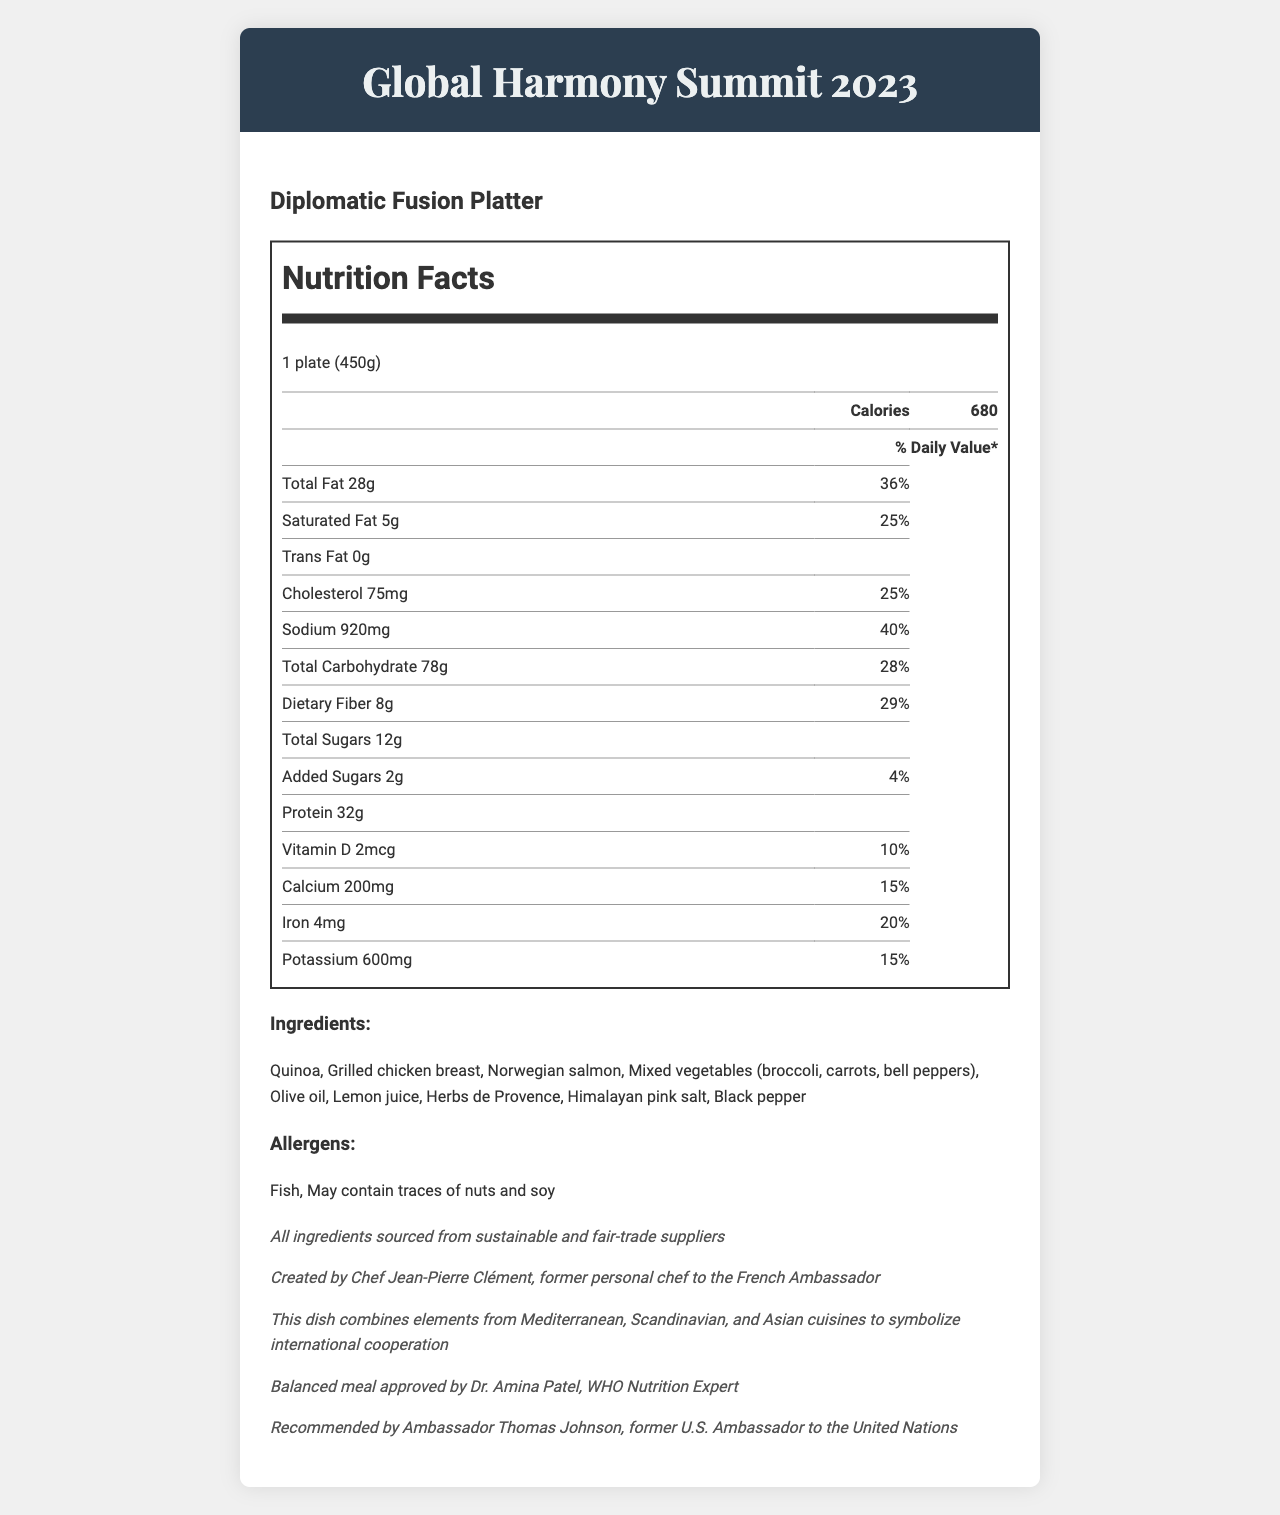what is the serving size of the Diplomatic Fusion Platter? The serving size is mentioned in the content section as "1 plate (450g)".
Answer: 1 plate (450g) how many calories are in one serving of the Diplomatic Fusion Platter? The calorie content is listed in bold under the nutrition facts section as "Calories 680".
Answer: 680 What is the main source of protein in the Diplomatic Fusion Platter? The ingredients list includes "Grilled chicken breast" and "Norwegian salmon," which are typically high in protein.
Answer: Grilled chicken breast, Norwegian salmon What is the daily value percentage for sodium? The sodium's daily value percentage is listed under the nutrition facts section as "Sodium 920mg 40%".
Answer: 40% Who created the Diplomatic Fusion Platter? The chef note states that the dish was created by Chef Jean-Pierre Clément.
Answer: Chef Jean-Pierre Clément Which ingredient is not included in the Diplomatic Fusion Platter? A. Quinoa B. Mixed vegetables C. Lentils D. Salmon The ingredients list does not mention "Lentils."
Answer: C. Lentils What is the daily value percentage for dietary fiber? A. 29% B. 28% C. 25% D. 20% The daily value percentage for dietary fiber is mentioned as "29%" under the nutrition facts section.
Answer: A. 29% Is the Diplomatic Fusion Platter suitable for individuals with a nut allergy? The allergens section states that the dish "May contain traces of nuts."
Answer: No Does the Diplomatic Fusion Platter include any added sugars? The document lists "Added Sugars 2g 4%" in the nutrition facts section.
Answer: Yes Briefly summarize the main idea of the document. The summary captures the essence of the document by detailing the nutritional information, ingredients, and additional notes on the preparation and approval of the Diplomatic Fusion Platter.
Answer: The document presents the nutrition facts, ingredients, and other details of the Diplomatic Fusion Platter served at the Global Harmony Summit 2023. It provides information on calorie content, daily value percentages for various nutrients, ingredients used, and any allergens present. The dish is created by Chef Jean-Pierre Clément and endorsed by notable figures, emphasizing its cultural fusion and sustainability. What is the total carbohydrate content of the Diplomatic Fusion Platter? The total carbohydrate content is stated as "Total Carbohydrate 78g" in the nutrition facts section.
Answer: 78g What is the daily value percentage for calcium? The daily value percentage for calcium is listed under the nutrition facts section as "Calcium 200mg 15%".
Answer: 15% What cuisines are combined in the Diplomatic Fusion Platter? The cultural fusion note mentions that the dish combines elements from Mediterranean, Scandinavian, and Asian cuisines.
Answer: Mediterranean, Scandinavian, and Asian cuisines What is the amount of potassium in the Diplomatic Fusion Platter? The potassium content is listed under the nutrition facts section as "Potassium 600mg".
Answer: 600mg Who approved the Diplomatic Fusion Platter as a balanced meal? The nutritionist approval note states that the balanced meal was approved by Dr. Amina Patel, WHO Nutrition Expert.
Answer: Dr. Amina Patel What is the percentage of daily value for vitamin D? A. 15% B. 20% C. 10% D. 5% The daily value percentage for vitamin D is listed as "Vitamin D 2mcg 10%" in the nutrition facts section.
Answer: C. 10% How many servings per container are there for the Diplomatic Fusion Platter? The servings per container are mentioned as "1" in the nutrition facts section.
Answer: 1 Who recommended the Diplomatic Fusion Platter? The ambassador endorsement note states that the dish is recommended by Ambassador Thomas Johnson, former U.S. Ambassador to the United Nations.
Answer: Ambassador Thomas Johnson What type of salt is used in the Diplomatic Fusion Platter? The ingredients section lists "Himalayan pink salt".
Answer: Himalayan pink salt How many grams of saturated fat are in the Diplomatic Fusion Platter? The saturated fat content is listed under the nutrition facts section as "Saturated Fat 5g".
Answer: 5g Explain the sustainability note mentioned in the document. The sustainability note explicitly states that "All ingredients sourced from sustainable and fair-trade suppliers".
Answer: All ingredients are sourced from sustainable and fair-trade suppliers Is there any trans fat in the Diplomatic Fusion Platter? The document lists "Trans Fat 0g" under the nutrition facts section.
Answer: No What is the cultural significance of the Diplomatic Fusion Platter? The cultural fusion note explains that the dish represents international cooperation through its diverse culinary elements.
Answer: It symbolizes international cooperation by combining elements from Mediterranean, Scandinavian, and Asian cuisines. What is the purpose of Chef Jean-Pierre Clément's note in the document? The chef note mentions Chef Jean-Pierre Clément's background as the former personal chef to the French Ambassador, lending credibility and prestige to the dish.
Answer: To provide credibility and highlight the chef's experience and background. 